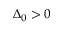<formula> <loc_0><loc_0><loc_500><loc_500>\Delta _ { 0 } > 0</formula> 